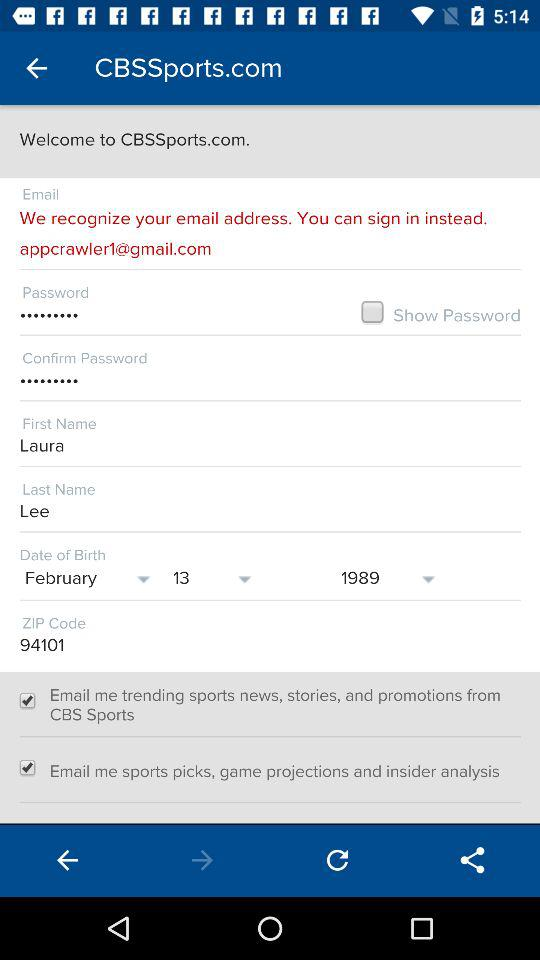What is the selected date of birth? The selected date of birth is February 13, 1989. 